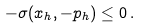<formula> <loc_0><loc_0><loc_500><loc_500>- \sigma ( x _ { h } , - p _ { h } ) \leq 0 \, .</formula> 